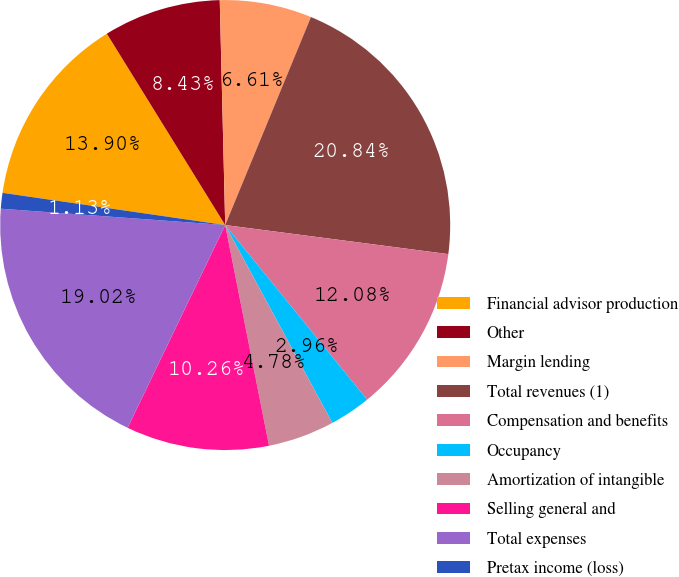Convert chart to OTSL. <chart><loc_0><loc_0><loc_500><loc_500><pie_chart><fcel>Financial advisor production<fcel>Other<fcel>Margin lending<fcel>Total revenues (1)<fcel>Compensation and benefits<fcel>Occupancy<fcel>Amortization of intangible<fcel>Selling general and<fcel>Total expenses<fcel>Pretax income (loss)<nl><fcel>13.9%<fcel>8.43%<fcel>6.61%<fcel>20.84%<fcel>12.08%<fcel>2.96%<fcel>4.78%<fcel>10.26%<fcel>19.02%<fcel>1.13%<nl></chart> 